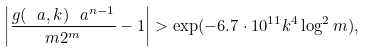Convert formula to latex. <formula><loc_0><loc_0><loc_500><loc_500>\left | \frac { g ( \ a , k ) \ a ^ { n - 1 } } { m 2 ^ { m } } - 1 \right | > \exp ( - 6 . 7 \cdot 1 0 ^ { 1 1 } k ^ { 4 } \log ^ { 2 } m ) ,</formula> 